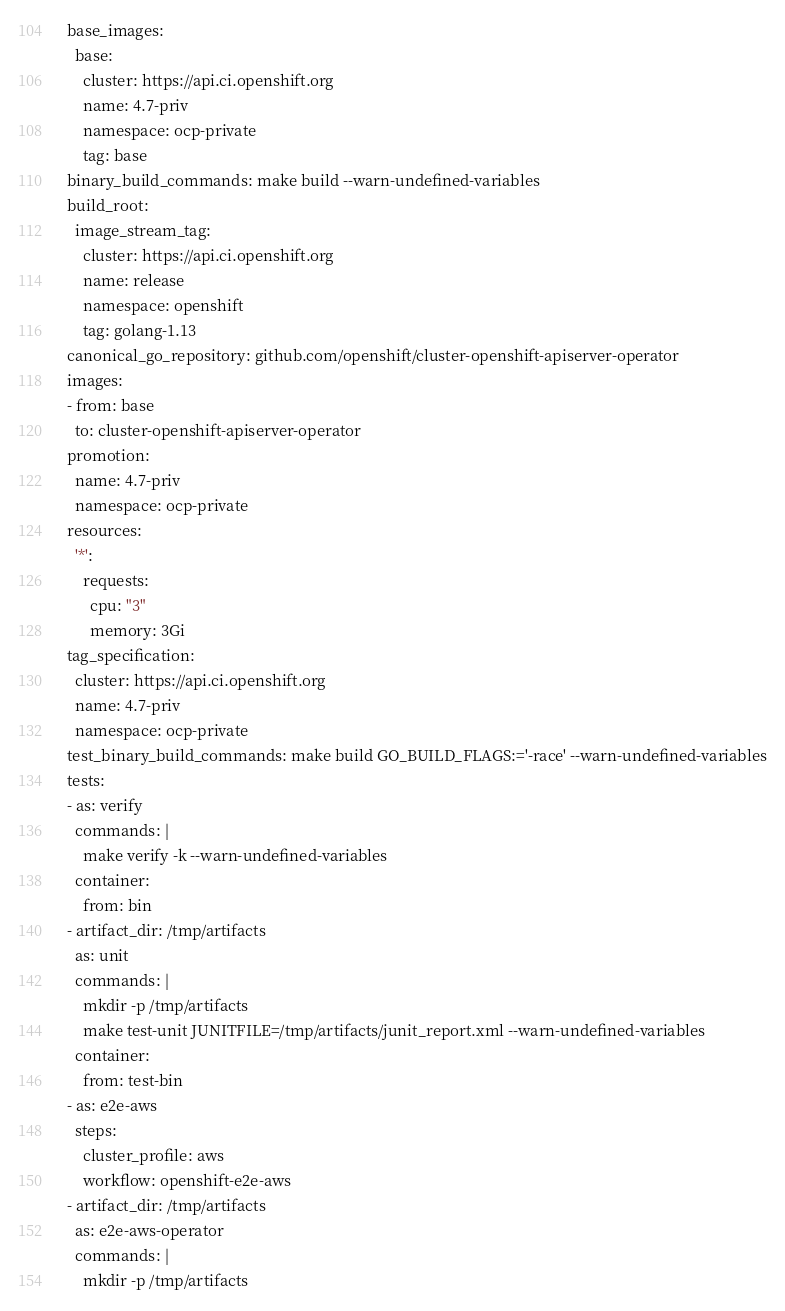Convert code to text. <code><loc_0><loc_0><loc_500><loc_500><_YAML_>base_images:
  base:
    cluster: https://api.ci.openshift.org
    name: 4.7-priv
    namespace: ocp-private
    tag: base
binary_build_commands: make build --warn-undefined-variables
build_root:
  image_stream_tag:
    cluster: https://api.ci.openshift.org
    name: release
    namespace: openshift
    tag: golang-1.13
canonical_go_repository: github.com/openshift/cluster-openshift-apiserver-operator
images:
- from: base
  to: cluster-openshift-apiserver-operator
promotion:
  name: 4.7-priv
  namespace: ocp-private
resources:
  '*':
    requests:
      cpu: "3"
      memory: 3Gi
tag_specification:
  cluster: https://api.ci.openshift.org
  name: 4.7-priv
  namespace: ocp-private
test_binary_build_commands: make build GO_BUILD_FLAGS:='-race' --warn-undefined-variables
tests:
- as: verify
  commands: |
    make verify -k --warn-undefined-variables
  container:
    from: bin
- artifact_dir: /tmp/artifacts
  as: unit
  commands: |
    mkdir -p /tmp/artifacts
    make test-unit JUNITFILE=/tmp/artifacts/junit_report.xml --warn-undefined-variables
  container:
    from: test-bin
- as: e2e-aws
  steps:
    cluster_profile: aws
    workflow: openshift-e2e-aws
- artifact_dir: /tmp/artifacts
  as: e2e-aws-operator
  commands: |
    mkdir -p /tmp/artifacts</code> 